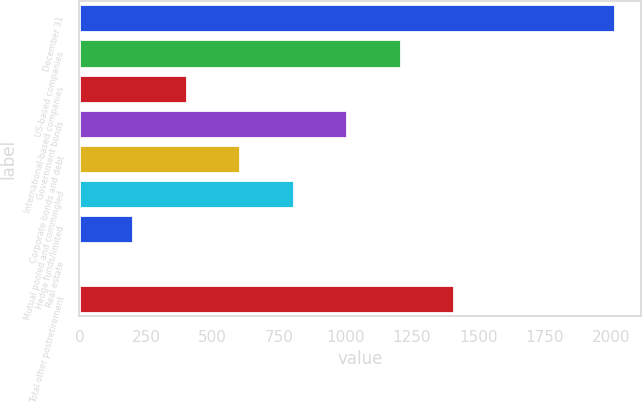<chart> <loc_0><loc_0><loc_500><loc_500><bar_chart><fcel>December 31<fcel>US-based companies<fcel>International-based companies<fcel>Government bonds<fcel>Corporate bonds and debt<fcel>Mutual pooled and commingled<fcel>Hedge funds/limited<fcel>Real estate<fcel>Total other postretirement<nl><fcel>2012<fcel>1208<fcel>404<fcel>1007<fcel>605<fcel>806<fcel>203<fcel>2<fcel>1409<nl></chart> 